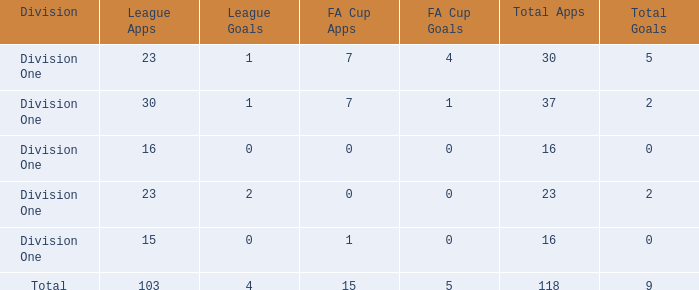It has fa cup goals larger than 0 and total goals of 0, what is the average total apps? None. 